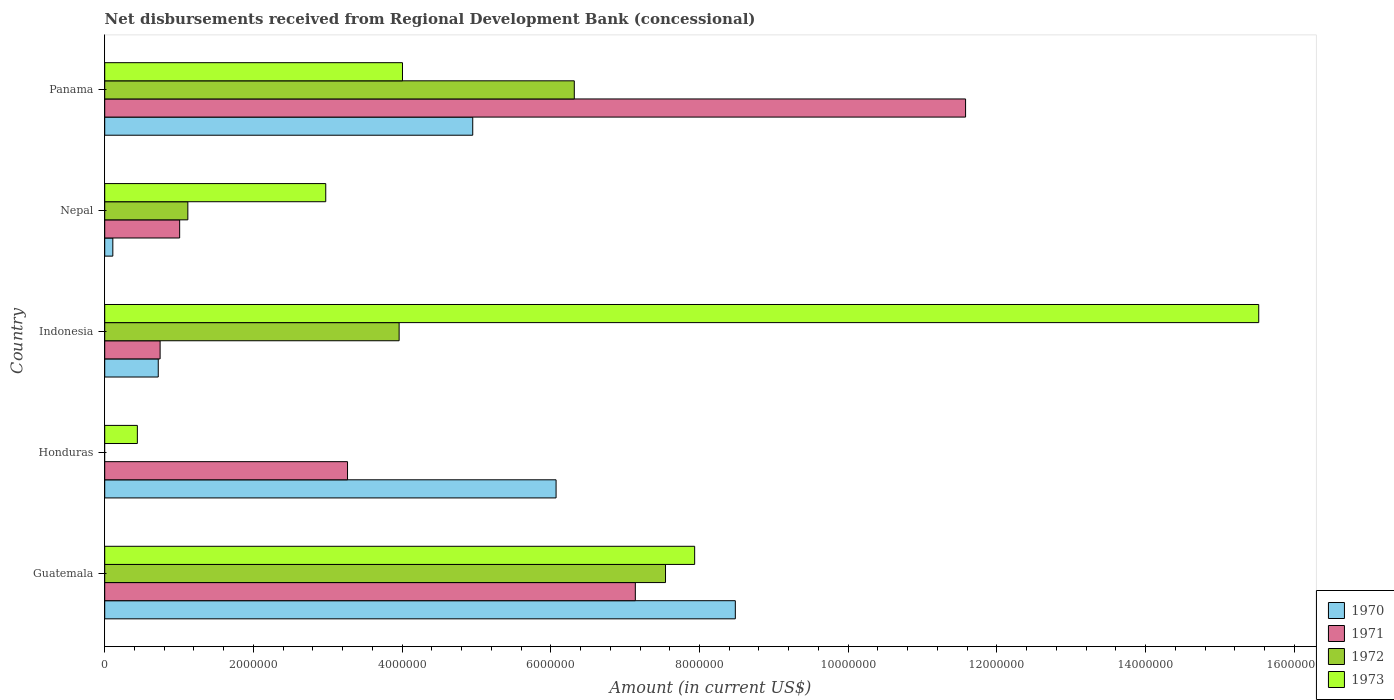How many different coloured bars are there?
Give a very brief answer. 4. Are the number of bars per tick equal to the number of legend labels?
Provide a short and direct response. No. How many bars are there on the 5th tick from the bottom?
Your response must be concise. 4. What is the label of the 4th group of bars from the top?
Ensure brevity in your answer.  Honduras. What is the amount of disbursements received from Regional Development Bank in 1971 in Nepal?
Offer a very short reply. 1.01e+06. Across all countries, what is the maximum amount of disbursements received from Regional Development Bank in 1970?
Provide a succinct answer. 8.48e+06. Across all countries, what is the minimum amount of disbursements received from Regional Development Bank in 1971?
Offer a very short reply. 7.45e+05. In which country was the amount of disbursements received from Regional Development Bank in 1972 maximum?
Your answer should be very brief. Guatemala. What is the total amount of disbursements received from Regional Development Bank in 1973 in the graph?
Offer a terse response. 3.09e+07. What is the difference between the amount of disbursements received from Regional Development Bank in 1972 in Guatemala and that in Indonesia?
Your answer should be very brief. 3.58e+06. What is the difference between the amount of disbursements received from Regional Development Bank in 1972 in Guatemala and the amount of disbursements received from Regional Development Bank in 1970 in Indonesia?
Ensure brevity in your answer.  6.82e+06. What is the average amount of disbursements received from Regional Development Bank in 1971 per country?
Keep it short and to the point. 4.75e+06. What is the difference between the amount of disbursements received from Regional Development Bank in 1971 and amount of disbursements received from Regional Development Bank in 1970 in Nepal?
Offer a very short reply. 8.99e+05. In how many countries, is the amount of disbursements received from Regional Development Bank in 1973 greater than 6800000 US$?
Provide a short and direct response. 2. What is the ratio of the amount of disbursements received from Regional Development Bank in 1970 in Honduras to that in Panama?
Your response must be concise. 1.23. What is the difference between the highest and the second highest amount of disbursements received from Regional Development Bank in 1972?
Give a very brief answer. 1.23e+06. What is the difference between the highest and the lowest amount of disbursements received from Regional Development Bank in 1972?
Provide a short and direct response. 7.54e+06. Is it the case that in every country, the sum of the amount of disbursements received from Regional Development Bank in 1973 and amount of disbursements received from Regional Development Bank in 1972 is greater than the amount of disbursements received from Regional Development Bank in 1970?
Offer a terse response. No. Are all the bars in the graph horizontal?
Your answer should be compact. Yes. How many countries are there in the graph?
Provide a short and direct response. 5. Are the values on the major ticks of X-axis written in scientific E-notation?
Make the answer very short. No. How are the legend labels stacked?
Make the answer very short. Vertical. What is the title of the graph?
Offer a terse response. Net disbursements received from Regional Development Bank (concessional). What is the label or title of the X-axis?
Provide a short and direct response. Amount (in current US$). What is the label or title of the Y-axis?
Give a very brief answer. Country. What is the Amount (in current US$) in 1970 in Guatemala?
Give a very brief answer. 8.48e+06. What is the Amount (in current US$) of 1971 in Guatemala?
Your response must be concise. 7.14e+06. What is the Amount (in current US$) of 1972 in Guatemala?
Provide a succinct answer. 7.54e+06. What is the Amount (in current US$) of 1973 in Guatemala?
Provide a short and direct response. 7.94e+06. What is the Amount (in current US$) of 1970 in Honduras?
Your answer should be very brief. 6.07e+06. What is the Amount (in current US$) in 1971 in Honduras?
Provide a short and direct response. 3.27e+06. What is the Amount (in current US$) of 1972 in Honduras?
Offer a very short reply. 0. What is the Amount (in current US$) in 1973 in Honduras?
Your answer should be very brief. 4.39e+05. What is the Amount (in current US$) in 1970 in Indonesia?
Ensure brevity in your answer.  7.20e+05. What is the Amount (in current US$) of 1971 in Indonesia?
Your response must be concise. 7.45e+05. What is the Amount (in current US$) in 1972 in Indonesia?
Your answer should be compact. 3.96e+06. What is the Amount (in current US$) of 1973 in Indonesia?
Your answer should be compact. 1.55e+07. What is the Amount (in current US$) of 1970 in Nepal?
Make the answer very short. 1.09e+05. What is the Amount (in current US$) in 1971 in Nepal?
Your answer should be very brief. 1.01e+06. What is the Amount (in current US$) of 1972 in Nepal?
Give a very brief answer. 1.12e+06. What is the Amount (in current US$) of 1973 in Nepal?
Your response must be concise. 2.97e+06. What is the Amount (in current US$) of 1970 in Panama?
Ensure brevity in your answer.  4.95e+06. What is the Amount (in current US$) of 1971 in Panama?
Give a very brief answer. 1.16e+07. What is the Amount (in current US$) in 1972 in Panama?
Your answer should be compact. 6.32e+06. What is the Amount (in current US$) of 1973 in Panama?
Ensure brevity in your answer.  4.00e+06. Across all countries, what is the maximum Amount (in current US$) of 1970?
Offer a very short reply. 8.48e+06. Across all countries, what is the maximum Amount (in current US$) of 1971?
Your response must be concise. 1.16e+07. Across all countries, what is the maximum Amount (in current US$) in 1972?
Keep it short and to the point. 7.54e+06. Across all countries, what is the maximum Amount (in current US$) in 1973?
Your answer should be very brief. 1.55e+07. Across all countries, what is the minimum Amount (in current US$) in 1970?
Ensure brevity in your answer.  1.09e+05. Across all countries, what is the minimum Amount (in current US$) in 1971?
Keep it short and to the point. 7.45e+05. Across all countries, what is the minimum Amount (in current US$) in 1973?
Provide a short and direct response. 4.39e+05. What is the total Amount (in current US$) of 1970 in the graph?
Provide a succinct answer. 2.03e+07. What is the total Amount (in current US$) of 1971 in the graph?
Offer a very short reply. 2.37e+07. What is the total Amount (in current US$) in 1972 in the graph?
Offer a very short reply. 1.89e+07. What is the total Amount (in current US$) in 1973 in the graph?
Your answer should be very brief. 3.09e+07. What is the difference between the Amount (in current US$) in 1970 in Guatemala and that in Honduras?
Provide a short and direct response. 2.41e+06. What is the difference between the Amount (in current US$) in 1971 in Guatemala and that in Honduras?
Make the answer very short. 3.87e+06. What is the difference between the Amount (in current US$) of 1973 in Guatemala and that in Honduras?
Your response must be concise. 7.50e+06. What is the difference between the Amount (in current US$) of 1970 in Guatemala and that in Indonesia?
Offer a very short reply. 7.76e+06. What is the difference between the Amount (in current US$) of 1971 in Guatemala and that in Indonesia?
Give a very brief answer. 6.39e+06. What is the difference between the Amount (in current US$) in 1972 in Guatemala and that in Indonesia?
Offer a terse response. 3.58e+06. What is the difference between the Amount (in current US$) in 1973 in Guatemala and that in Indonesia?
Ensure brevity in your answer.  -7.59e+06. What is the difference between the Amount (in current US$) of 1970 in Guatemala and that in Nepal?
Provide a succinct answer. 8.37e+06. What is the difference between the Amount (in current US$) in 1971 in Guatemala and that in Nepal?
Keep it short and to the point. 6.13e+06. What is the difference between the Amount (in current US$) of 1972 in Guatemala and that in Nepal?
Your answer should be compact. 6.42e+06. What is the difference between the Amount (in current US$) of 1973 in Guatemala and that in Nepal?
Your answer should be very brief. 4.96e+06. What is the difference between the Amount (in current US$) of 1970 in Guatemala and that in Panama?
Make the answer very short. 3.53e+06. What is the difference between the Amount (in current US$) of 1971 in Guatemala and that in Panama?
Offer a very short reply. -4.44e+06. What is the difference between the Amount (in current US$) of 1972 in Guatemala and that in Panama?
Your answer should be compact. 1.23e+06. What is the difference between the Amount (in current US$) of 1973 in Guatemala and that in Panama?
Ensure brevity in your answer.  3.93e+06. What is the difference between the Amount (in current US$) in 1970 in Honduras and that in Indonesia?
Your answer should be very brief. 5.35e+06. What is the difference between the Amount (in current US$) of 1971 in Honduras and that in Indonesia?
Offer a very short reply. 2.52e+06. What is the difference between the Amount (in current US$) in 1973 in Honduras and that in Indonesia?
Your response must be concise. -1.51e+07. What is the difference between the Amount (in current US$) of 1970 in Honduras and that in Nepal?
Offer a terse response. 5.96e+06. What is the difference between the Amount (in current US$) in 1971 in Honduras and that in Nepal?
Your answer should be compact. 2.26e+06. What is the difference between the Amount (in current US$) in 1973 in Honduras and that in Nepal?
Provide a succinct answer. -2.53e+06. What is the difference between the Amount (in current US$) in 1970 in Honduras and that in Panama?
Offer a very short reply. 1.12e+06. What is the difference between the Amount (in current US$) of 1971 in Honduras and that in Panama?
Keep it short and to the point. -8.31e+06. What is the difference between the Amount (in current US$) of 1973 in Honduras and that in Panama?
Provide a succinct answer. -3.57e+06. What is the difference between the Amount (in current US$) in 1970 in Indonesia and that in Nepal?
Offer a very short reply. 6.11e+05. What is the difference between the Amount (in current US$) in 1971 in Indonesia and that in Nepal?
Make the answer very short. -2.63e+05. What is the difference between the Amount (in current US$) of 1972 in Indonesia and that in Nepal?
Make the answer very short. 2.84e+06. What is the difference between the Amount (in current US$) of 1973 in Indonesia and that in Nepal?
Keep it short and to the point. 1.25e+07. What is the difference between the Amount (in current US$) in 1970 in Indonesia and that in Panama?
Offer a terse response. -4.23e+06. What is the difference between the Amount (in current US$) of 1971 in Indonesia and that in Panama?
Offer a very short reply. -1.08e+07. What is the difference between the Amount (in current US$) in 1972 in Indonesia and that in Panama?
Give a very brief answer. -2.36e+06. What is the difference between the Amount (in current US$) in 1973 in Indonesia and that in Panama?
Ensure brevity in your answer.  1.15e+07. What is the difference between the Amount (in current US$) of 1970 in Nepal and that in Panama?
Make the answer very short. -4.84e+06. What is the difference between the Amount (in current US$) of 1971 in Nepal and that in Panama?
Your answer should be compact. -1.06e+07. What is the difference between the Amount (in current US$) in 1972 in Nepal and that in Panama?
Offer a very short reply. -5.20e+06. What is the difference between the Amount (in current US$) of 1973 in Nepal and that in Panama?
Make the answer very short. -1.03e+06. What is the difference between the Amount (in current US$) of 1970 in Guatemala and the Amount (in current US$) of 1971 in Honduras?
Your answer should be compact. 5.22e+06. What is the difference between the Amount (in current US$) in 1970 in Guatemala and the Amount (in current US$) in 1973 in Honduras?
Provide a short and direct response. 8.04e+06. What is the difference between the Amount (in current US$) in 1971 in Guatemala and the Amount (in current US$) in 1973 in Honduras?
Your answer should be very brief. 6.70e+06. What is the difference between the Amount (in current US$) in 1972 in Guatemala and the Amount (in current US$) in 1973 in Honduras?
Keep it short and to the point. 7.10e+06. What is the difference between the Amount (in current US$) of 1970 in Guatemala and the Amount (in current US$) of 1971 in Indonesia?
Keep it short and to the point. 7.74e+06. What is the difference between the Amount (in current US$) in 1970 in Guatemala and the Amount (in current US$) in 1972 in Indonesia?
Your answer should be very brief. 4.52e+06. What is the difference between the Amount (in current US$) in 1970 in Guatemala and the Amount (in current US$) in 1973 in Indonesia?
Give a very brief answer. -7.04e+06. What is the difference between the Amount (in current US$) of 1971 in Guatemala and the Amount (in current US$) of 1972 in Indonesia?
Provide a succinct answer. 3.18e+06. What is the difference between the Amount (in current US$) in 1971 in Guatemala and the Amount (in current US$) in 1973 in Indonesia?
Your answer should be very brief. -8.38e+06. What is the difference between the Amount (in current US$) in 1972 in Guatemala and the Amount (in current US$) in 1973 in Indonesia?
Provide a succinct answer. -7.98e+06. What is the difference between the Amount (in current US$) in 1970 in Guatemala and the Amount (in current US$) in 1971 in Nepal?
Your response must be concise. 7.47e+06. What is the difference between the Amount (in current US$) in 1970 in Guatemala and the Amount (in current US$) in 1972 in Nepal?
Provide a short and direct response. 7.36e+06. What is the difference between the Amount (in current US$) in 1970 in Guatemala and the Amount (in current US$) in 1973 in Nepal?
Offer a very short reply. 5.51e+06. What is the difference between the Amount (in current US$) of 1971 in Guatemala and the Amount (in current US$) of 1972 in Nepal?
Provide a succinct answer. 6.02e+06. What is the difference between the Amount (in current US$) in 1971 in Guatemala and the Amount (in current US$) in 1973 in Nepal?
Ensure brevity in your answer.  4.16e+06. What is the difference between the Amount (in current US$) of 1972 in Guatemala and the Amount (in current US$) of 1973 in Nepal?
Offer a very short reply. 4.57e+06. What is the difference between the Amount (in current US$) in 1970 in Guatemala and the Amount (in current US$) in 1971 in Panama?
Your answer should be compact. -3.10e+06. What is the difference between the Amount (in current US$) of 1970 in Guatemala and the Amount (in current US$) of 1972 in Panama?
Make the answer very short. 2.17e+06. What is the difference between the Amount (in current US$) of 1970 in Guatemala and the Amount (in current US$) of 1973 in Panama?
Provide a succinct answer. 4.48e+06. What is the difference between the Amount (in current US$) in 1971 in Guatemala and the Amount (in current US$) in 1972 in Panama?
Your answer should be very brief. 8.21e+05. What is the difference between the Amount (in current US$) of 1971 in Guatemala and the Amount (in current US$) of 1973 in Panama?
Make the answer very short. 3.13e+06. What is the difference between the Amount (in current US$) in 1972 in Guatemala and the Amount (in current US$) in 1973 in Panama?
Ensure brevity in your answer.  3.54e+06. What is the difference between the Amount (in current US$) in 1970 in Honduras and the Amount (in current US$) in 1971 in Indonesia?
Your answer should be very brief. 5.33e+06. What is the difference between the Amount (in current US$) of 1970 in Honduras and the Amount (in current US$) of 1972 in Indonesia?
Keep it short and to the point. 2.11e+06. What is the difference between the Amount (in current US$) of 1970 in Honduras and the Amount (in current US$) of 1973 in Indonesia?
Make the answer very short. -9.45e+06. What is the difference between the Amount (in current US$) of 1971 in Honduras and the Amount (in current US$) of 1972 in Indonesia?
Provide a short and direct response. -6.94e+05. What is the difference between the Amount (in current US$) in 1971 in Honduras and the Amount (in current US$) in 1973 in Indonesia?
Make the answer very short. -1.23e+07. What is the difference between the Amount (in current US$) of 1970 in Honduras and the Amount (in current US$) of 1971 in Nepal?
Offer a very short reply. 5.06e+06. What is the difference between the Amount (in current US$) of 1970 in Honduras and the Amount (in current US$) of 1972 in Nepal?
Your answer should be compact. 4.95e+06. What is the difference between the Amount (in current US$) of 1970 in Honduras and the Amount (in current US$) of 1973 in Nepal?
Make the answer very short. 3.10e+06. What is the difference between the Amount (in current US$) of 1971 in Honduras and the Amount (in current US$) of 1972 in Nepal?
Provide a succinct answer. 2.15e+06. What is the difference between the Amount (in current US$) in 1971 in Honduras and the Amount (in current US$) in 1973 in Nepal?
Your answer should be very brief. 2.93e+05. What is the difference between the Amount (in current US$) in 1970 in Honduras and the Amount (in current US$) in 1971 in Panama?
Your response must be concise. -5.51e+06. What is the difference between the Amount (in current US$) in 1970 in Honduras and the Amount (in current US$) in 1972 in Panama?
Your answer should be compact. -2.45e+05. What is the difference between the Amount (in current US$) in 1970 in Honduras and the Amount (in current US$) in 1973 in Panama?
Give a very brief answer. 2.07e+06. What is the difference between the Amount (in current US$) of 1971 in Honduras and the Amount (in current US$) of 1972 in Panama?
Offer a very short reply. -3.05e+06. What is the difference between the Amount (in current US$) in 1971 in Honduras and the Amount (in current US$) in 1973 in Panama?
Provide a short and direct response. -7.39e+05. What is the difference between the Amount (in current US$) of 1970 in Indonesia and the Amount (in current US$) of 1971 in Nepal?
Your answer should be very brief. -2.88e+05. What is the difference between the Amount (in current US$) of 1970 in Indonesia and the Amount (in current US$) of 1972 in Nepal?
Offer a very short reply. -3.98e+05. What is the difference between the Amount (in current US$) in 1970 in Indonesia and the Amount (in current US$) in 1973 in Nepal?
Give a very brief answer. -2.25e+06. What is the difference between the Amount (in current US$) of 1971 in Indonesia and the Amount (in current US$) of 1972 in Nepal?
Offer a very short reply. -3.73e+05. What is the difference between the Amount (in current US$) in 1971 in Indonesia and the Amount (in current US$) in 1973 in Nepal?
Your response must be concise. -2.23e+06. What is the difference between the Amount (in current US$) of 1972 in Indonesia and the Amount (in current US$) of 1973 in Nepal?
Your answer should be very brief. 9.87e+05. What is the difference between the Amount (in current US$) in 1970 in Indonesia and the Amount (in current US$) in 1971 in Panama?
Make the answer very short. -1.09e+07. What is the difference between the Amount (in current US$) in 1970 in Indonesia and the Amount (in current US$) in 1972 in Panama?
Ensure brevity in your answer.  -5.60e+06. What is the difference between the Amount (in current US$) of 1970 in Indonesia and the Amount (in current US$) of 1973 in Panama?
Provide a succinct answer. -3.28e+06. What is the difference between the Amount (in current US$) of 1971 in Indonesia and the Amount (in current US$) of 1972 in Panama?
Provide a succinct answer. -5.57e+06. What is the difference between the Amount (in current US$) of 1971 in Indonesia and the Amount (in current US$) of 1973 in Panama?
Your answer should be compact. -3.26e+06. What is the difference between the Amount (in current US$) of 1972 in Indonesia and the Amount (in current US$) of 1973 in Panama?
Make the answer very short. -4.50e+04. What is the difference between the Amount (in current US$) of 1970 in Nepal and the Amount (in current US$) of 1971 in Panama?
Make the answer very short. -1.15e+07. What is the difference between the Amount (in current US$) in 1970 in Nepal and the Amount (in current US$) in 1972 in Panama?
Provide a short and direct response. -6.21e+06. What is the difference between the Amount (in current US$) of 1970 in Nepal and the Amount (in current US$) of 1973 in Panama?
Keep it short and to the point. -3.90e+06. What is the difference between the Amount (in current US$) of 1971 in Nepal and the Amount (in current US$) of 1972 in Panama?
Your answer should be very brief. -5.31e+06. What is the difference between the Amount (in current US$) of 1971 in Nepal and the Amount (in current US$) of 1973 in Panama?
Your answer should be compact. -3.00e+06. What is the difference between the Amount (in current US$) in 1972 in Nepal and the Amount (in current US$) in 1973 in Panama?
Provide a short and direct response. -2.89e+06. What is the average Amount (in current US$) in 1970 per country?
Your answer should be compact. 4.07e+06. What is the average Amount (in current US$) of 1971 per country?
Provide a short and direct response. 4.75e+06. What is the average Amount (in current US$) in 1972 per country?
Ensure brevity in your answer.  3.79e+06. What is the average Amount (in current US$) of 1973 per country?
Provide a short and direct response. 6.17e+06. What is the difference between the Amount (in current US$) of 1970 and Amount (in current US$) of 1971 in Guatemala?
Give a very brief answer. 1.34e+06. What is the difference between the Amount (in current US$) of 1970 and Amount (in current US$) of 1972 in Guatemala?
Offer a very short reply. 9.39e+05. What is the difference between the Amount (in current US$) in 1970 and Amount (in current US$) in 1973 in Guatemala?
Your answer should be very brief. 5.47e+05. What is the difference between the Amount (in current US$) of 1971 and Amount (in current US$) of 1972 in Guatemala?
Offer a very short reply. -4.06e+05. What is the difference between the Amount (in current US$) of 1971 and Amount (in current US$) of 1973 in Guatemala?
Provide a succinct answer. -7.98e+05. What is the difference between the Amount (in current US$) of 1972 and Amount (in current US$) of 1973 in Guatemala?
Give a very brief answer. -3.92e+05. What is the difference between the Amount (in current US$) in 1970 and Amount (in current US$) in 1971 in Honduras?
Provide a short and direct response. 2.80e+06. What is the difference between the Amount (in current US$) of 1970 and Amount (in current US$) of 1973 in Honduras?
Your answer should be very brief. 5.63e+06. What is the difference between the Amount (in current US$) in 1971 and Amount (in current US$) in 1973 in Honduras?
Provide a succinct answer. 2.83e+06. What is the difference between the Amount (in current US$) of 1970 and Amount (in current US$) of 1971 in Indonesia?
Offer a very short reply. -2.50e+04. What is the difference between the Amount (in current US$) in 1970 and Amount (in current US$) in 1972 in Indonesia?
Keep it short and to the point. -3.24e+06. What is the difference between the Amount (in current US$) of 1970 and Amount (in current US$) of 1973 in Indonesia?
Your answer should be very brief. -1.48e+07. What is the difference between the Amount (in current US$) in 1971 and Amount (in current US$) in 1972 in Indonesia?
Keep it short and to the point. -3.22e+06. What is the difference between the Amount (in current US$) in 1971 and Amount (in current US$) in 1973 in Indonesia?
Your response must be concise. -1.48e+07. What is the difference between the Amount (in current US$) in 1972 and Amount (in current US$) in 1973 in Indonesia?
Offer a terse response. -1.16e+07. What is the difference between the Amount (in current US$) of 1970 and Amount (in current US$) of 1971 in Nepal?
Your answer should be compact. -8.99e+05. What is the difference between the Amount (in current US$) of 1970 and Amount (in current US$) of 1972 in Nepal?
Give a very brief answer. -1.01e+06. What is the difference between the Amount (in current US$) of 1970 and Amount (in current US$) of 1973 in Nepal?
Offer a very short reply. -2.86e+06. What is the difference between the Amount (in current US$) of 1971 and Amount (in current US$) of 1972 in Nepal?
Offer a very short reply. -1.10e+05. What is the difference between the Amount (in current US$) in 1971 and Amount (in current US$) in 1973 in Nepal?
Offer a very short reply. -1.96e+06. What is the difference between the Amount (in current US$) of 1972 and Amount (in current US$) of 1973 in Nepal?
Provide a succinct answer. -1.86e+06. What is the difference between the Amount (in current US$) in 1970 and Amount (in current US$) in 1971 in Panama?
Give a very brief answer. -6.63e+06. What is the difference between the Amount (in current US$) in 1970 and Amount (in current US$) in 1972 in Panama?
Your answer should be very brief. -1.37e+06. What is the difference between the Amount (in current US$) of 1970 and Amount (in current US$) of 1973 in Panama?
Your response must be concise. 9.45e+05. What is the difference between the Amount (in current US$) in 1971 and Amount (in current US$) in 1972 in Panama?
Your response must be concise. 5.26e+06. What is the difference between the Amount (in current US$) of 1971 and Amount (in current US$) of 1973 in Panama?
Give a very brief answer. 7.57e+06. What is the difference between the Amount (in current US$) in 1972 and Amount (in current US$) in 1973 in Panama?
Offer a terse response. 2.31e+06. What is the ratio of the Amount (in current US$) of 1970 in Guatemala to that in Honduras?
Your response must be concise. 1.4. What is the ratio of the Amount (in current US$) of 1971 in Guatemala to that in Honduras?
Keep it short and to the point. 2.19. What is the ratio of the Amount (in current US$) in 1973 in Guatemala to that in Honduras?
Provide a short and direct response. 18.08. What is the ratio of the Amount (in current US$) in 1970 in Guatemala to that in Indonesia?
Offer a terse response. 11.78. What is the ratio of the Amount (in current US$) in 1971 in Guatemala to that in Indonesia?
Make the answer very short. 9.58. What is the ratio of the Amount (in current US$) of 1972 in Guatemala to that in Indonesia?
Offer a very short reply. 1.9. What is the ratio of the Amount (in current US$) of 1973 in Guatemala to that in Indonesia?
Give a very brief answer. 0.51. What is the ratio of the Amount (in current US$) in 1970 in Guatemala to that in Nepal?
Keep it short and to the point. 77.82. What is the ratio of the Amount (in current US$) in 1971 in Guatemala to that in Nepal?
Your answer should be compact. 7.08. What is the ratio of the Amount (in current US$) of 1972 in Guatemala to that in Nepal?
Your response must be concise. 6.75. What is the ratio of the Amount (in current US$) of 1973 in Guatemala to that in Nepal?
Offer a terse response. 2.67. What is the ratio of the Amount (in current US$) in 1970 in Guatemala to that in Panama?
Your answer should be very brief. 1.71. What is the ratio of the Amount (in current US$) in 1971 in Guatemala to that in Panama?
Keep it short and to the point. 0.62. What is the ratio of the Amount (in current US$) in 1972 in Guatemala to that in Panama?
Provide a succinct answer. 1.19. What is the ratio of the Amount (in current US$) in 1973 in Guatemala to that in Panama?
Offer a very short reply. 1.98. What is the ratio of the Amount (in current US$) of 1970 in Honduras to that in Indonesia?
Offer a terse response. 8.43. What is the ratio of the Amount (in current US$) in 1971 in Honduras to that in Indonesia?
Offer a terse response. 4.38. What is the ratio of the Amount (in current US$) in 1973 in Honduras to that in Indonesia?
Provide a succinct answer. 0.03. What is the ratio of the Amount (in current US$) of 1970 in Honduras to that in Nepal?
Provide a short and direct response. 55.7. What is the ratio of the Amount (in current US$) in 1971 in Honduras to that in Nepal?
Offer a terse response. 3.24. What is the ratio of the Amount (in current US$) in 1973 in Honduras to that in Nepal?
Your answer should be very brief. 0.15. What is the ratio of the Amount (in current US$) of 1970 in Honduras to that in Panama?
Offer a terse response. 1.23. What is the ratio of the Amount (in current US$) in 1971 in Honduras to that in Panama?
Your answer should be very brief. 0.28. What is the ratio of the Amount (in current US$) in 1973 in Honduras to that in Panama?
Give a very brief answer. 0.11. What is the ratio of the Amount (in current US$) of 1970 in Indonesia to that in Nepal?
Provide a short and direct response. 6.61. What is the ratio of the Amount (in current US$) of 1971 in Indonesia to that in Nepal?
Give a very brief answer. 0.74. What is the ratio of the Amount (in current US$) of 1972 in Indonesia to that in Nepal?
Provide a succinct answer. 3.54. What is the ratio of the Amount (in current US$) of 1973 in Indonesia to that in Nepal?
Keep it short and to the point. 5.22. What is the ratio of the Amount (in current US$) in 1970 in Indonesia to that in Panama?
Keep it short and to the point. 0.15. What is the ratio of the Amount (in current US$) in 1971 in Indonesia to that in Panama?
Your answer should be compact. 0.06. What is the ratio of the Amount (in current US$) in 1972 in Indonesia to that in Panama?
Provide a short and direct response. 0.63. What is the ratio of the Amount (in current US$) in 1973 in Indonesia to that in Panama?
Give a very brief answer. 3.88. What is the ratio of the Amount (in current US$) of 1970 in Nepal to that in Panama?
Make the answer very short. 0.02. What is the ratio of the Amount (in current US$) in 1971 in Nepal to that in Panama?
Provide a short and direct response. 0.09. What is the ratio of the Amount (in current US$) of 1972 in Nepal to that in Panama?
Ensure brevity in your answer.  0.18. What is the ratio of the Amount (in current US$) in 1973 in Nepal to that in Panama?
Make the answer very short. 0.74. What is the difference between the highest and the second highest Amount (in current US$) in 1970?
Your answer should be very brief. 2.41e+06. What is the difference between the highest and the second highest Amount (in current US$) in 1971?
Give a very brief answer. 4.44e+06. What is the difference between the highest and the second highest Amount (in current US$) of 1972?
Your answer should be very brief. 1.23e+06. What is the difference between the highest and the second highest Amount (in current US$) in 1973?
Your response must be concise. 7.59e+06. What is the difference between the highest and the lowest Amount (in current US$) in 1970?
Your answer should be compact. 8.37e+06. What is the difference between the highest and the lowest Amount (in current US$) in 1971?
Give a very brief answer. 1.08e+07. What is the difference between the highest and the lowest Amount (in current US$) of 1972?
Ensure brevity in your answer.  7.54e+06. What is the difference between the highest and the lowest Amount (in current US$) of 1973?
Your answer should be very brief. 1.51e+07. 